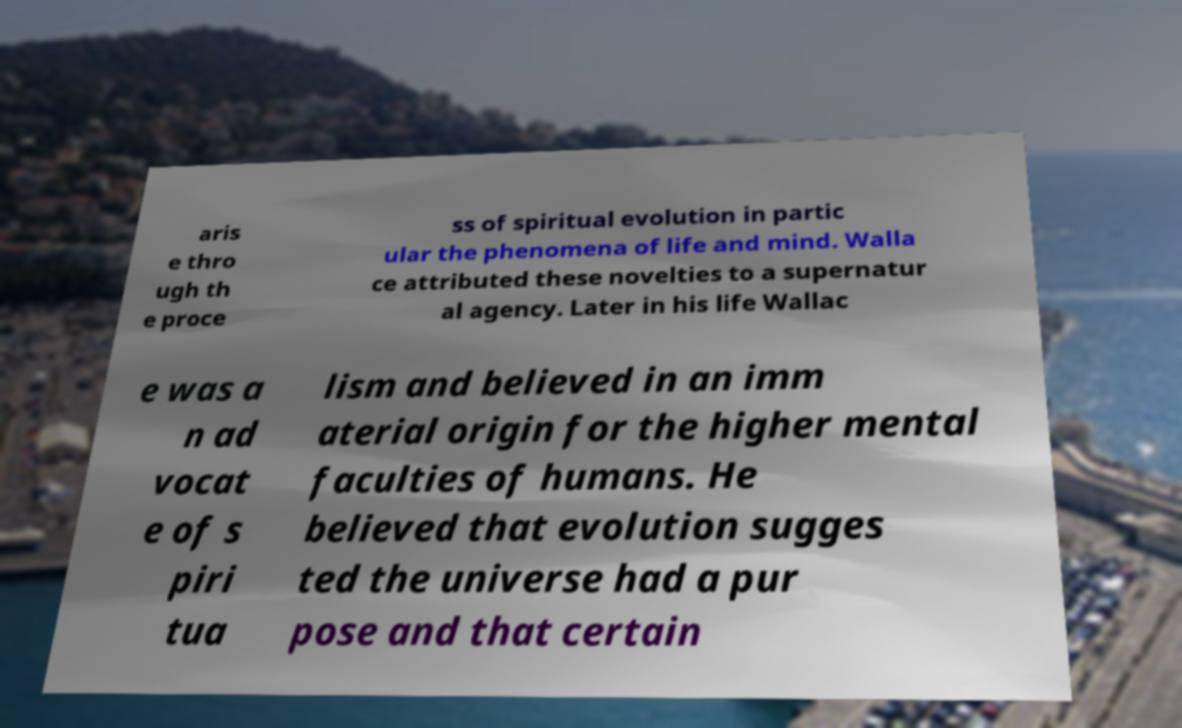Could you assist in decoding the text presented in this image and type it out clearly? aris e thro ugh th e proce ss of spiritual evolution in partic ular the phenomena of life and mind. Walla ce attributed these novelties to a supernatur al agency. Later in his life Wallac e was a n ad vocat e of s piri tua lism and believed in an imm aterial origin for the higher mental faculties of humans. He believed that evolution sugges ted the universe had a pur pose and that certain 